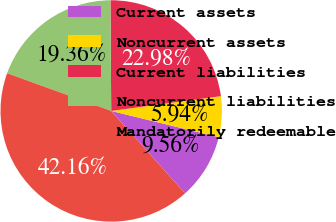Convert chart. <chart><loc_0><loc_0><loc_500><loc_500><pie_chart><fcel>Current assets<fcel>Noncurrent assets<fcel>Current liabilities<fcel>Noncurrent liabilities<fcel>Mandatorily redeemable<nl><fcel>9.56%<fcel>5.94%<fcel>22.98%<fcel>19.36%<fcel>42.16%<nl></chart> 